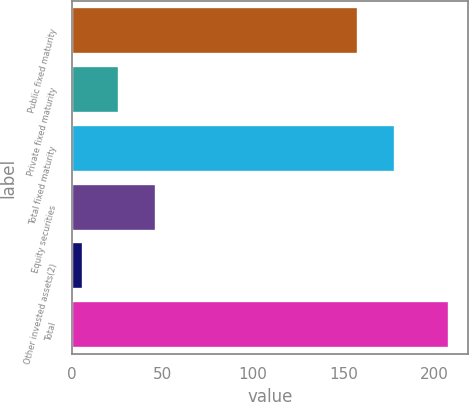Convert chart. <chart><loc_0><loc_0><loc_500><loc_500><bar_chart><fcel>Public fixed maturity<fcel>Private fixed maturity<fcel>Total fixed maturity<fcel>Equity securities<fcel>Other invested assets(2)<fcel>Total<nl><fcel>158<fcel>26.2<fcel>178.2<fcel>46.4<fcel>6<fcel>208<nl></chart> 